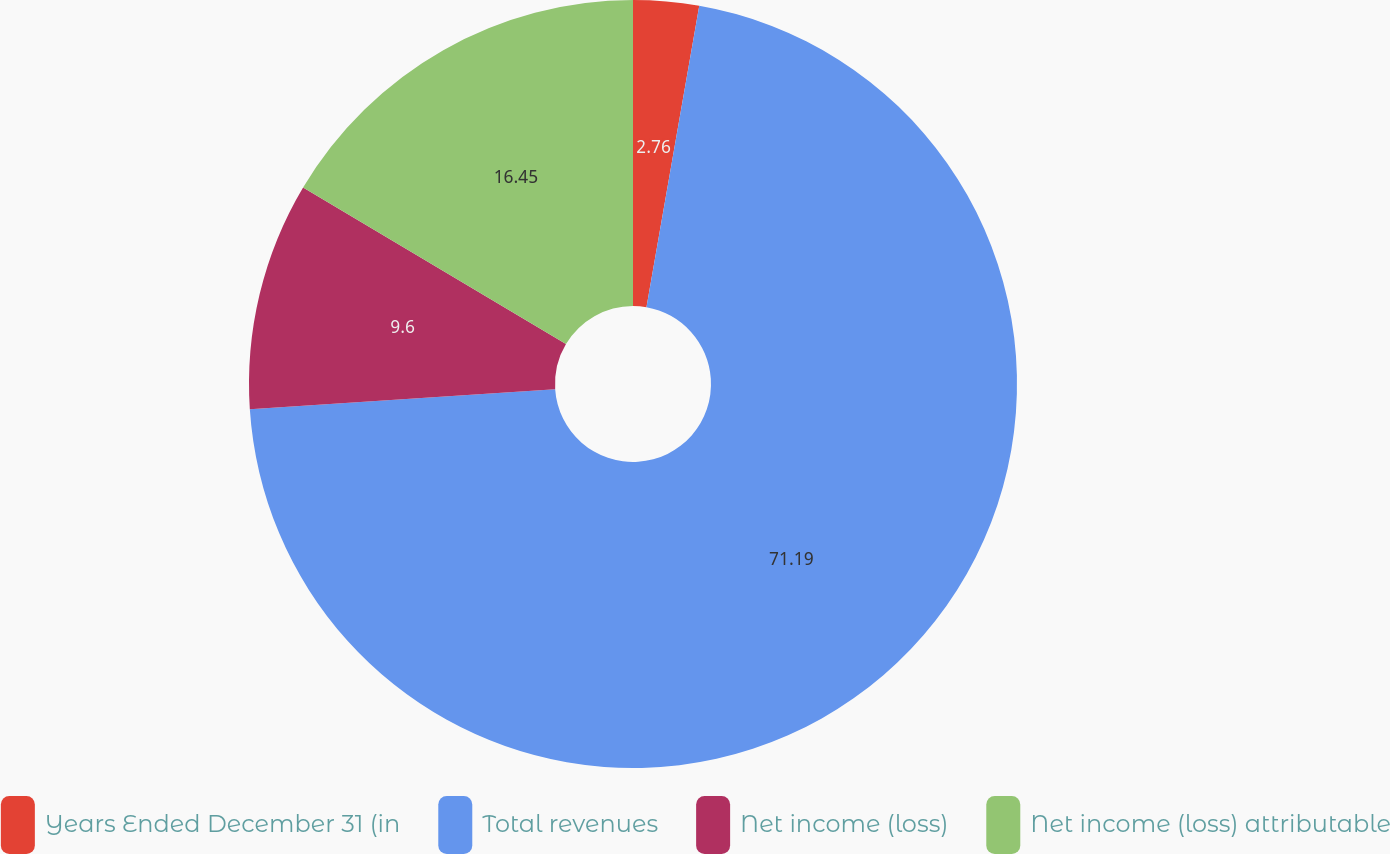<chart> <loc_0><loc_0><loc_500><loc_500><pie_chart><fcel>Years Ended December 31 (in<fcel>Total revenues<fcel>Net income (loss)<fcel>Net income (loss) attributable<nl><fcel>2.76%<fcel>71.19%<fcel>9.6%<fcel>16.45%<nl></chart> 